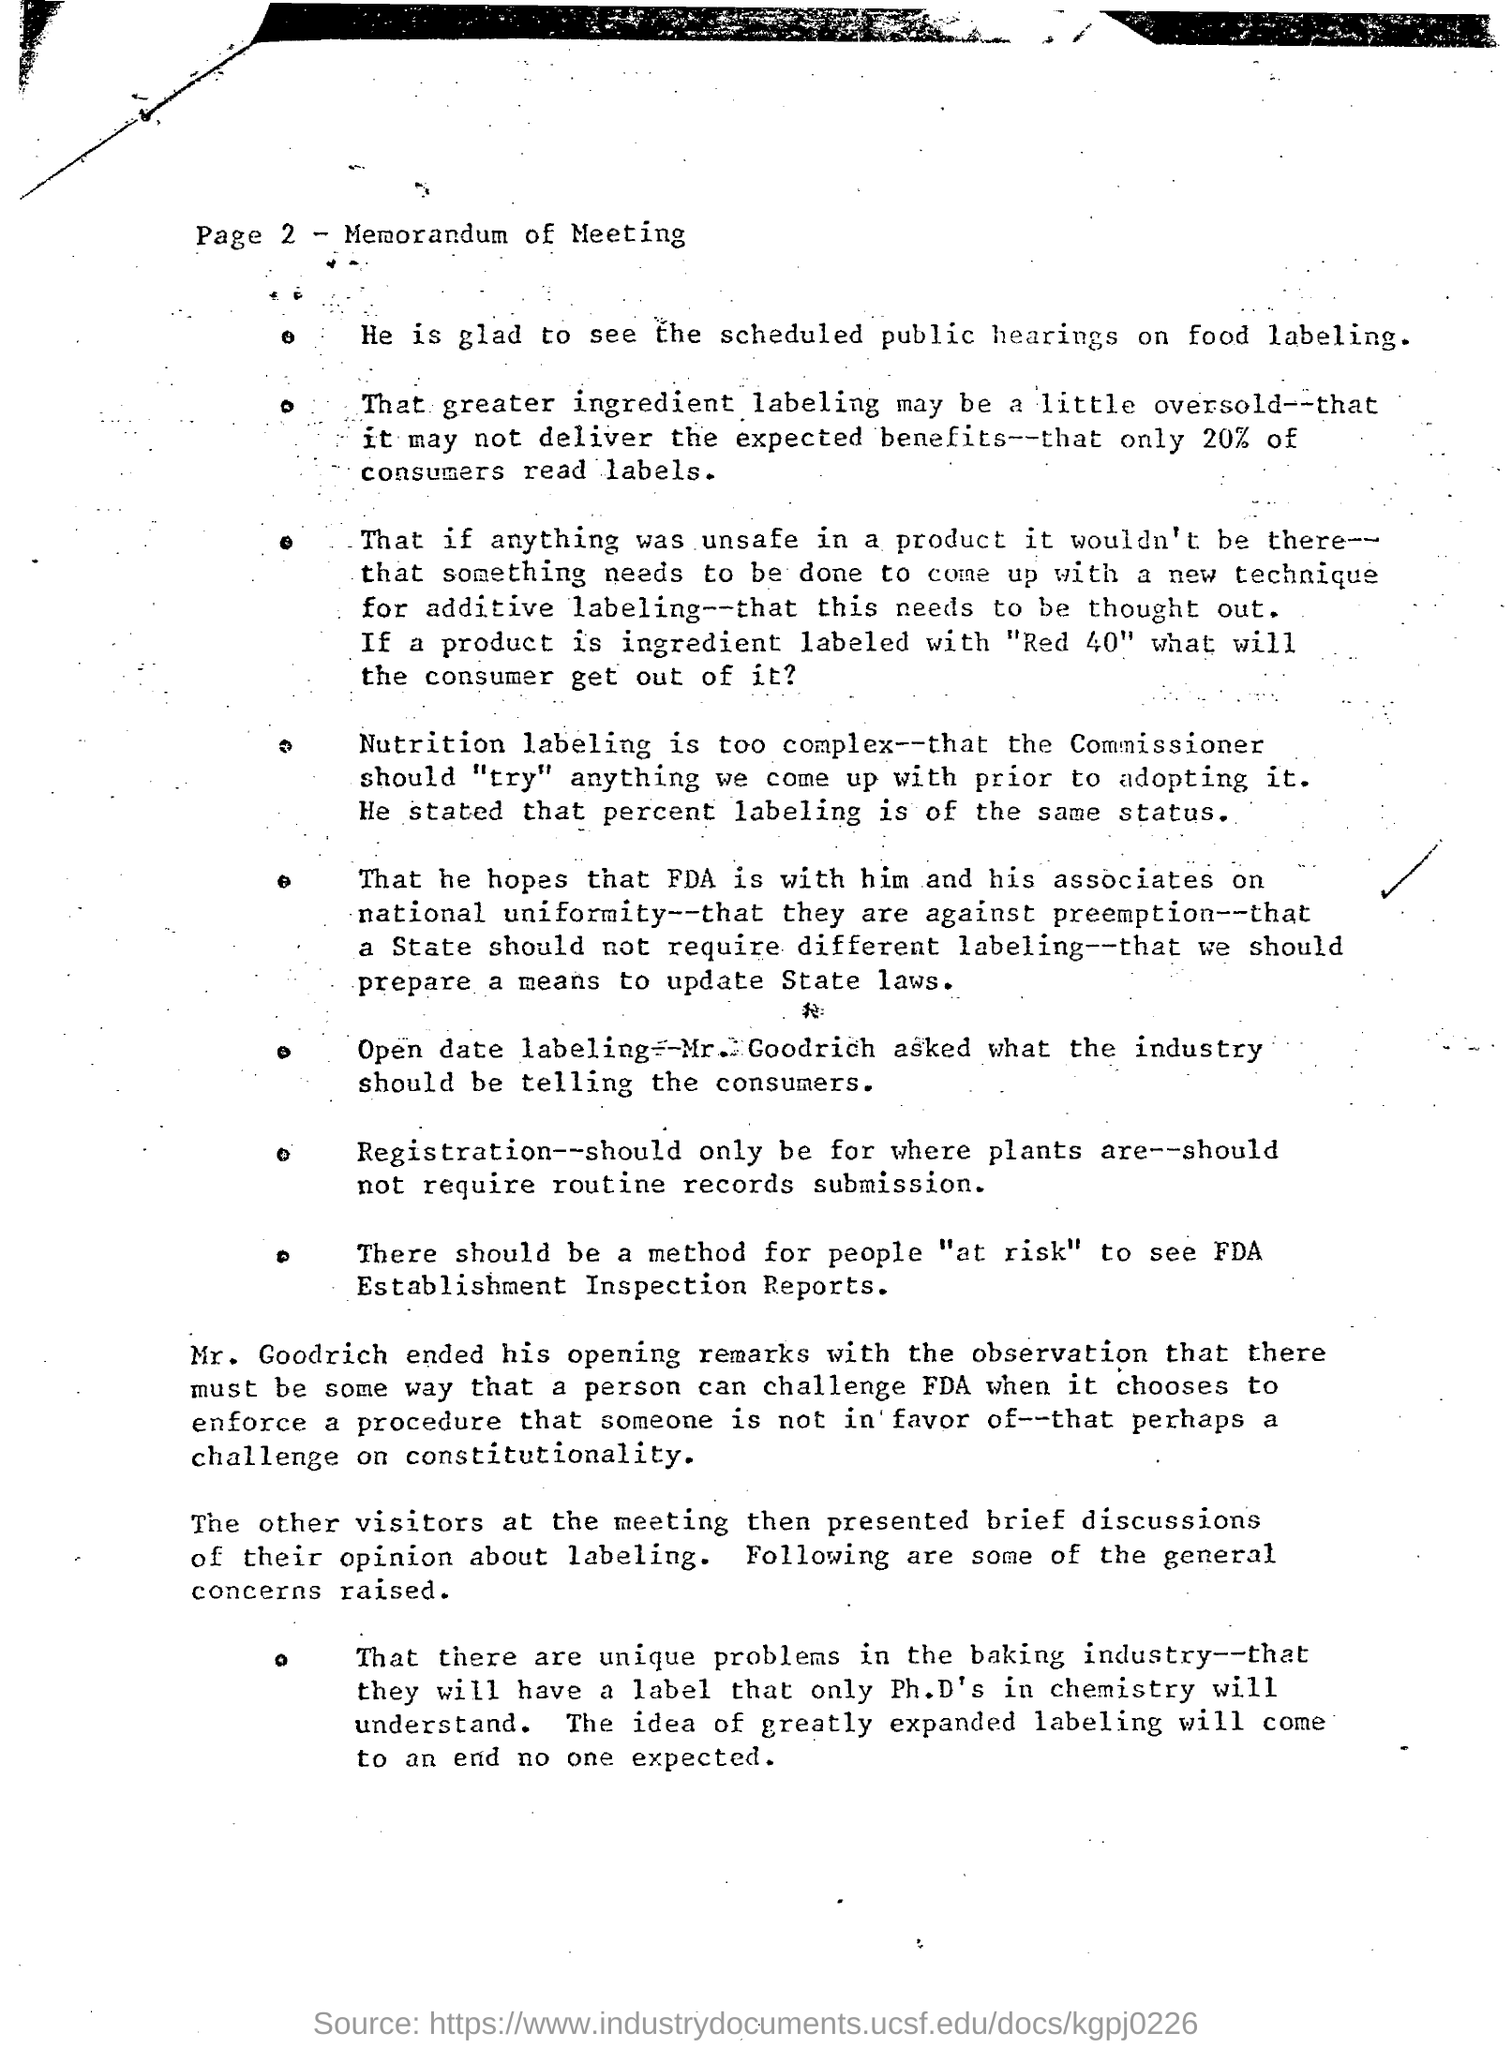What are the scheduled public gatherings on?
Provide a short and direct response. On food labeling. How much percent of consumers reads labels?
Offer a terse response. 20. What is the heading of the document?
Provide a succinct answer. Memorandum of meeting. 